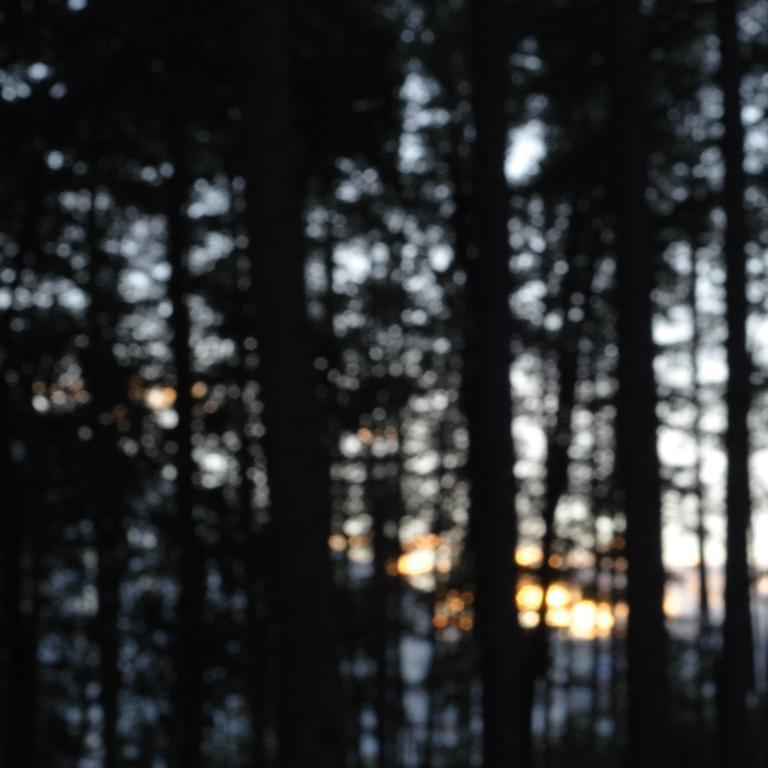What type of vegetation can be seen in the image? There are trees in the image. What is the source of light in the image? Light is visible in the image. What is the color scheme of the image? The image is black and white. What type of nut is being used to sew the cloth in the image? There is no nut or cloth present in the image; it only features trees and light. 